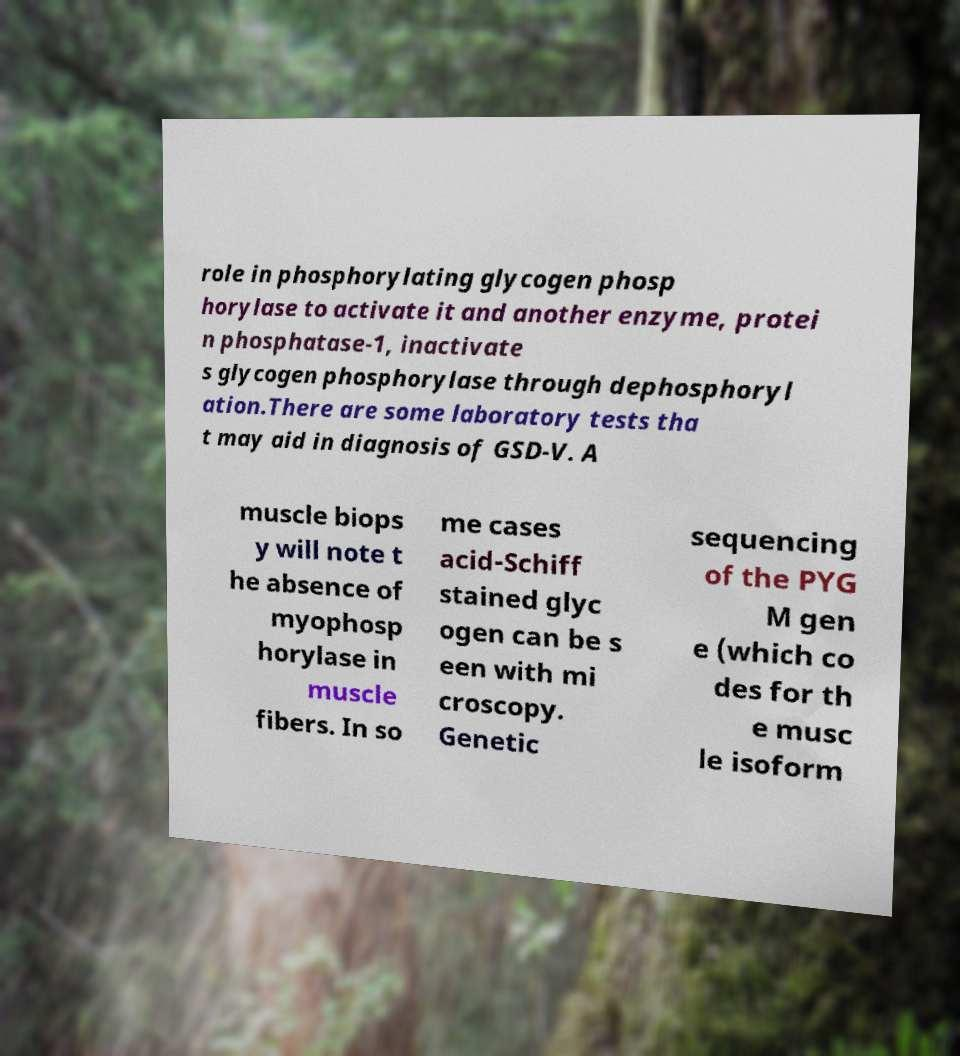There's text embedded in this image that I need extracted. Can you transcribe it verbatim? role in phosphorylating glycogen phosp horylase to activate it and another enzyme, protei n phosphatase-1, inactivate s glycogen phosphorylase through dephosphoryl ation.There are some laboratory tests tha t may aid in diagnosis of GSD-V. A muscle biops y will note t he absence of myophosp horylase in muscle fibers. In so me cases acid-Schiff stained glyc ogen can be s een with mi croscopy. Genetic sequencing of the PYG M gen e (which co des for th e musc le isoform 